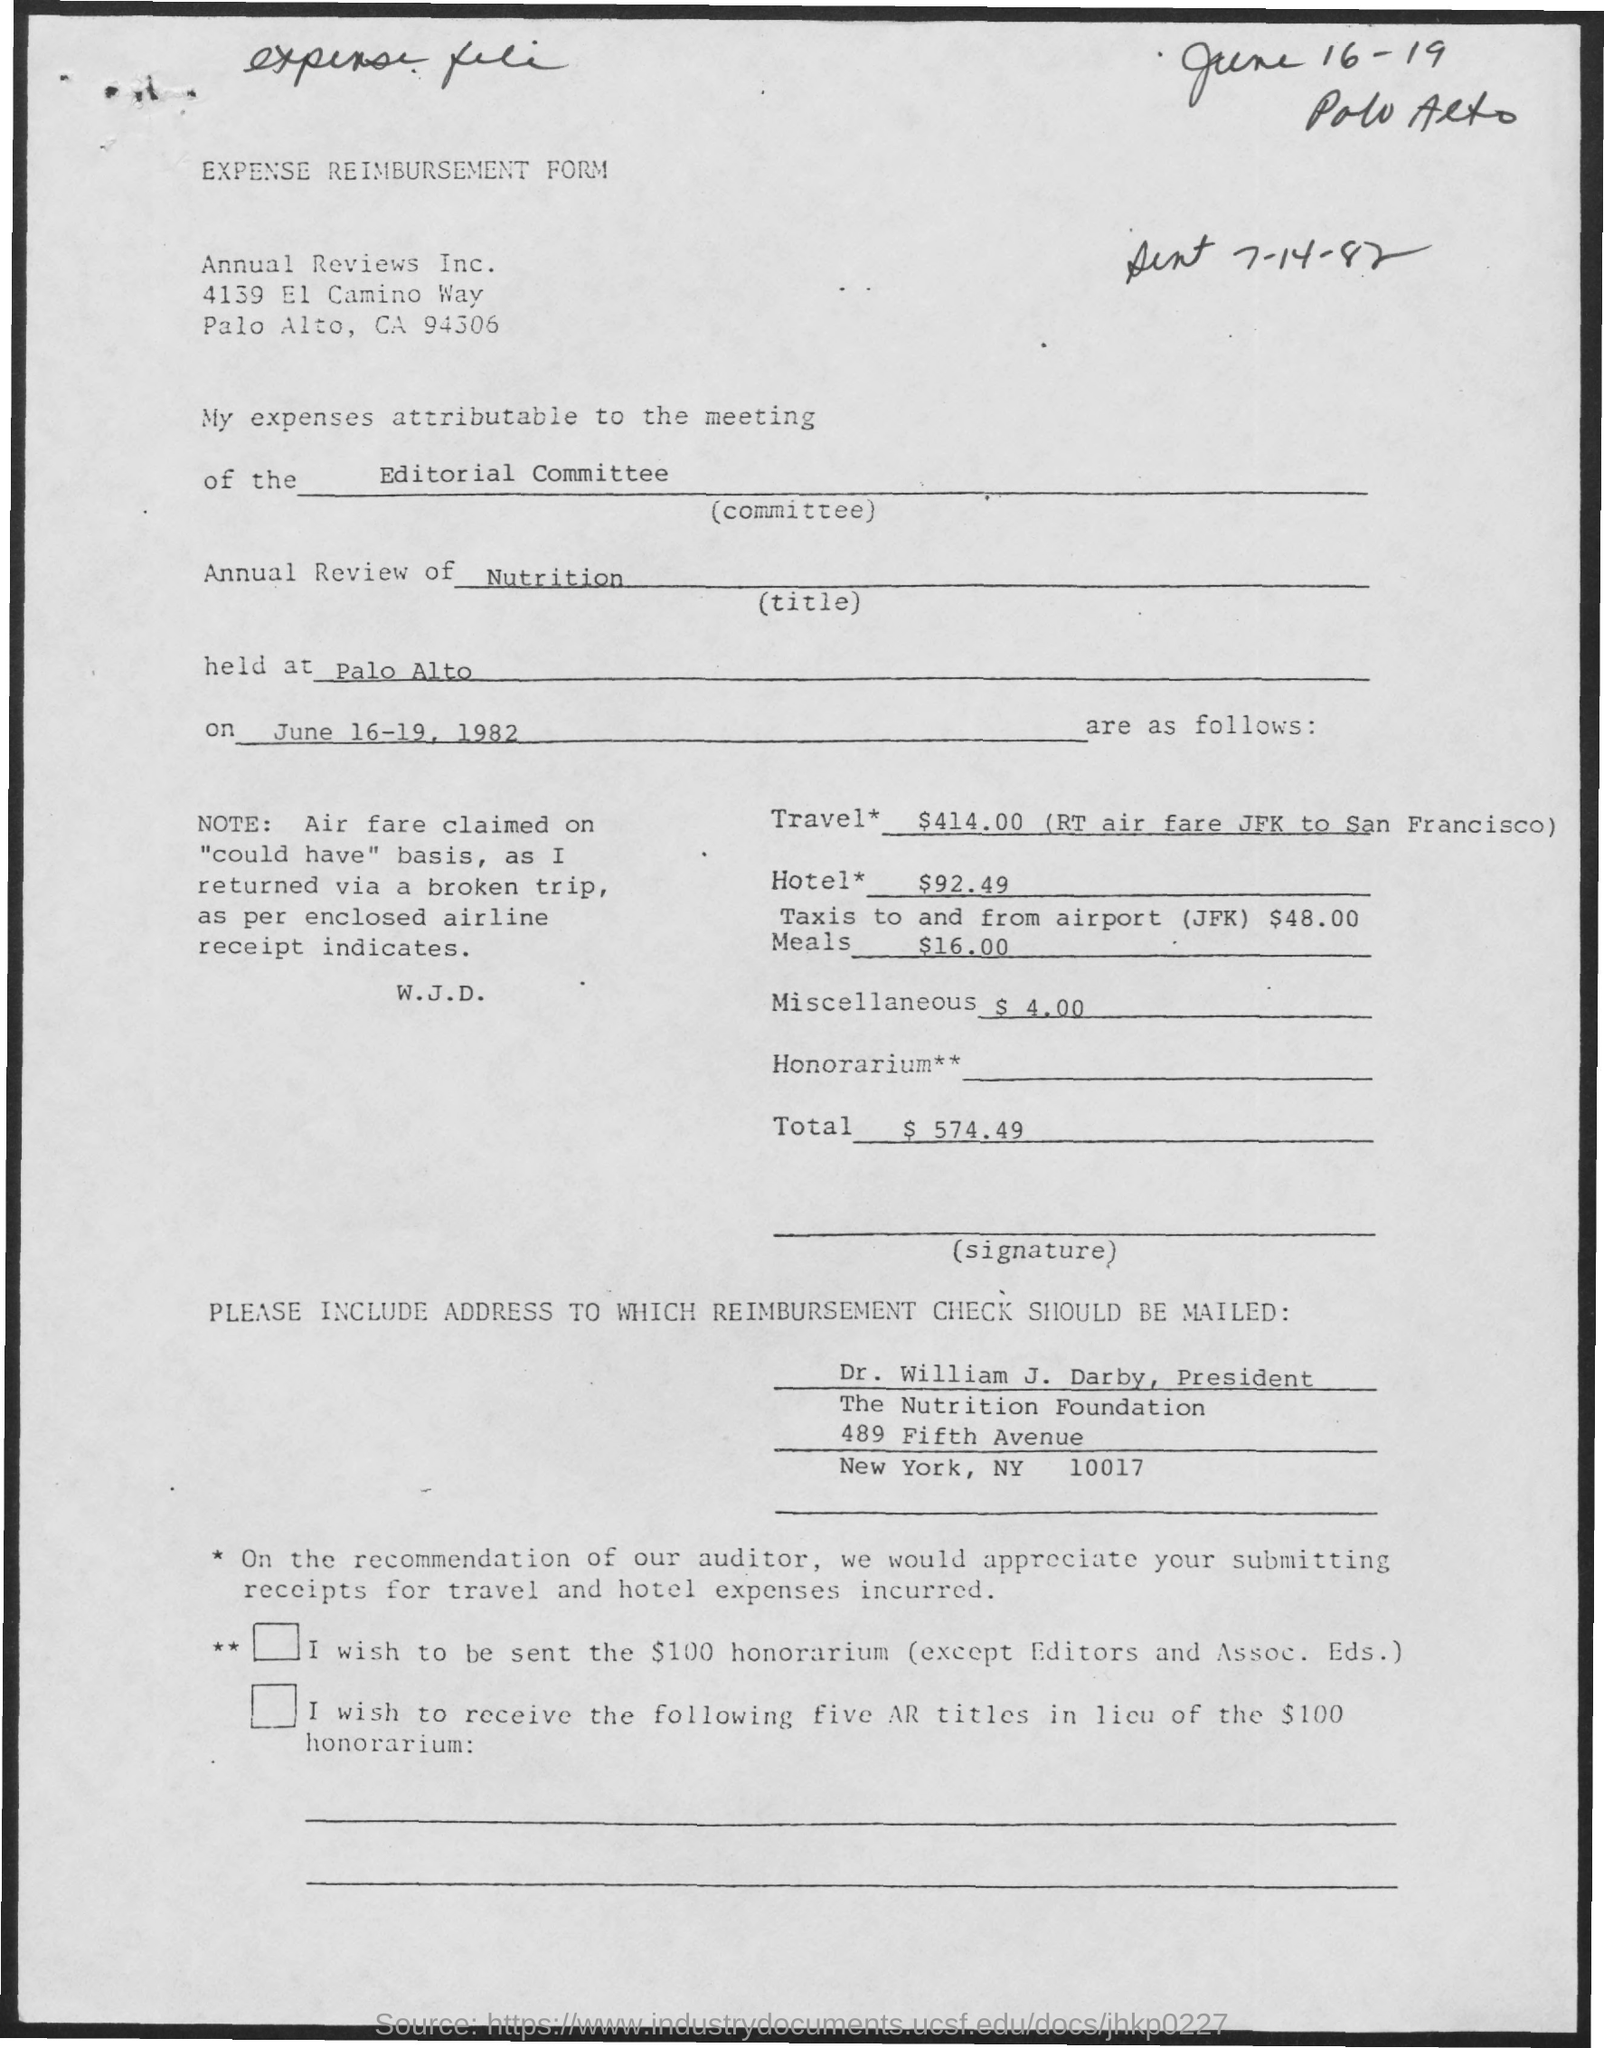Highlight a few significant elements in this photo. The name of the form is "Expense Reimbursement Form. The total expense amount is $574.49. The expense for the hotel is $92.49. The annual review is held at Palo Alto. An annual review title is a summary of a person's performance or progress for the past year, specifically in the field of nutrition. 